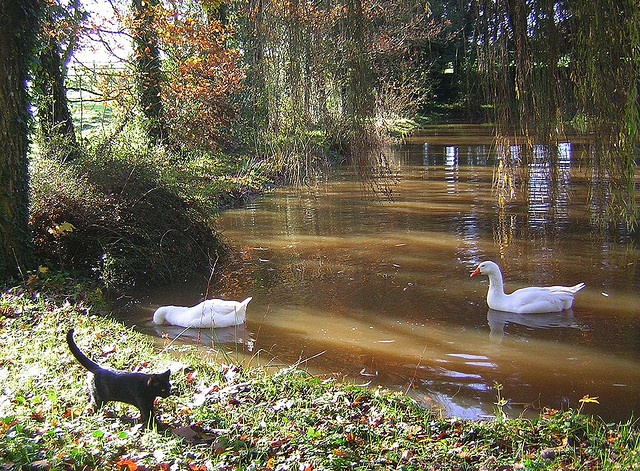Describe the objects in this image and their specific colors. I can see cat in black, ivory, navy, and gray tones, bird in black, lavender, gray, and darkgray tones, and bird in black, lavender, gray, and darkgray tones in this image. 